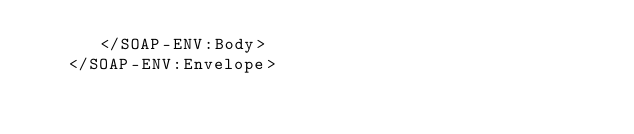Convert code to text. <code><loc_0><loc_0><loc_500><loc_500><_XML_>      </SOAP-ENV:Body>
   </SOAP-ENV:Envelope>
</code> 